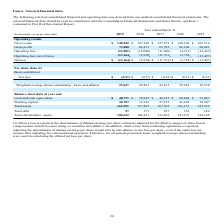According to Agilysys's financial document, What is the adjustment made to the denominator when loss is reported? the denominator of diluted earnings per share cannot be adjusted for the dilutive impact of share-based compensation awards because doing so would be anti-dilutive. The document states: "(1) When a loss is reported, the denominator of diluted earnings per share cannot be adjusted for the dilutive impact of share-based compensation awar..." Also, What calculation is used for diluted net loss per share? basic weighted-average shares outstanding. The document states: "operation. Therefore, for all periods presented, basic weighted-average shares outstanding were used in calculating the diluted net loss per share...." Also, What was the net revenue in 2019? According to the financial document, 140,842 (in thousands). The relevant text states: "Net revenue $ 140,842 $ 127,360 $ 127,678 $ 120,366 $ 103,514..." Also, can you calculate: What was the increase / (decrease) in the net revenue from 2018 to 2019? Based on the calculation: 140,842 - 127,360, the result is 13482 (in thousands). This is based on the information: "Net revenue $ 140,842 $ 127,360 $ 127,678 $ 120,366 $ 103,514 Net revenue $ 140,842 $ 127,360 $ 127,678 $ 120,366 $ 103,514..." The key data points involved are: 127,360, 140,842. Also, can you calculate: What is the average gross profit for 2018 and 2019? To answer this question, I need to perform calculations using the financial data. The calculation is: (73,880 + 64,417) / 2, which equals 69148.5 (in thousands). This is based on the information: "Gross profit 73,880 64,417 63,785 68,106 60,081 Gross profit 73,880 64,417 63,785 68,106 60,081..." The key data points involved are: 64,417, 73,880. Also, can you calculate: What is the average operating loss for 2018 and 2019? To answer this question, I need to perform calculations using the financial data. The calculation is: -(13,081 + 12,080) / 2, which equals -12580.5 (in thousands). This is based on the information: "Operating loss (13,081) (12,080) (11,408) (4,313) (12,467) Operating loss (13,081) (12,080) (11,408) (4,313) (12,467)..." The key data points involved are: 12,080, 13,081. 